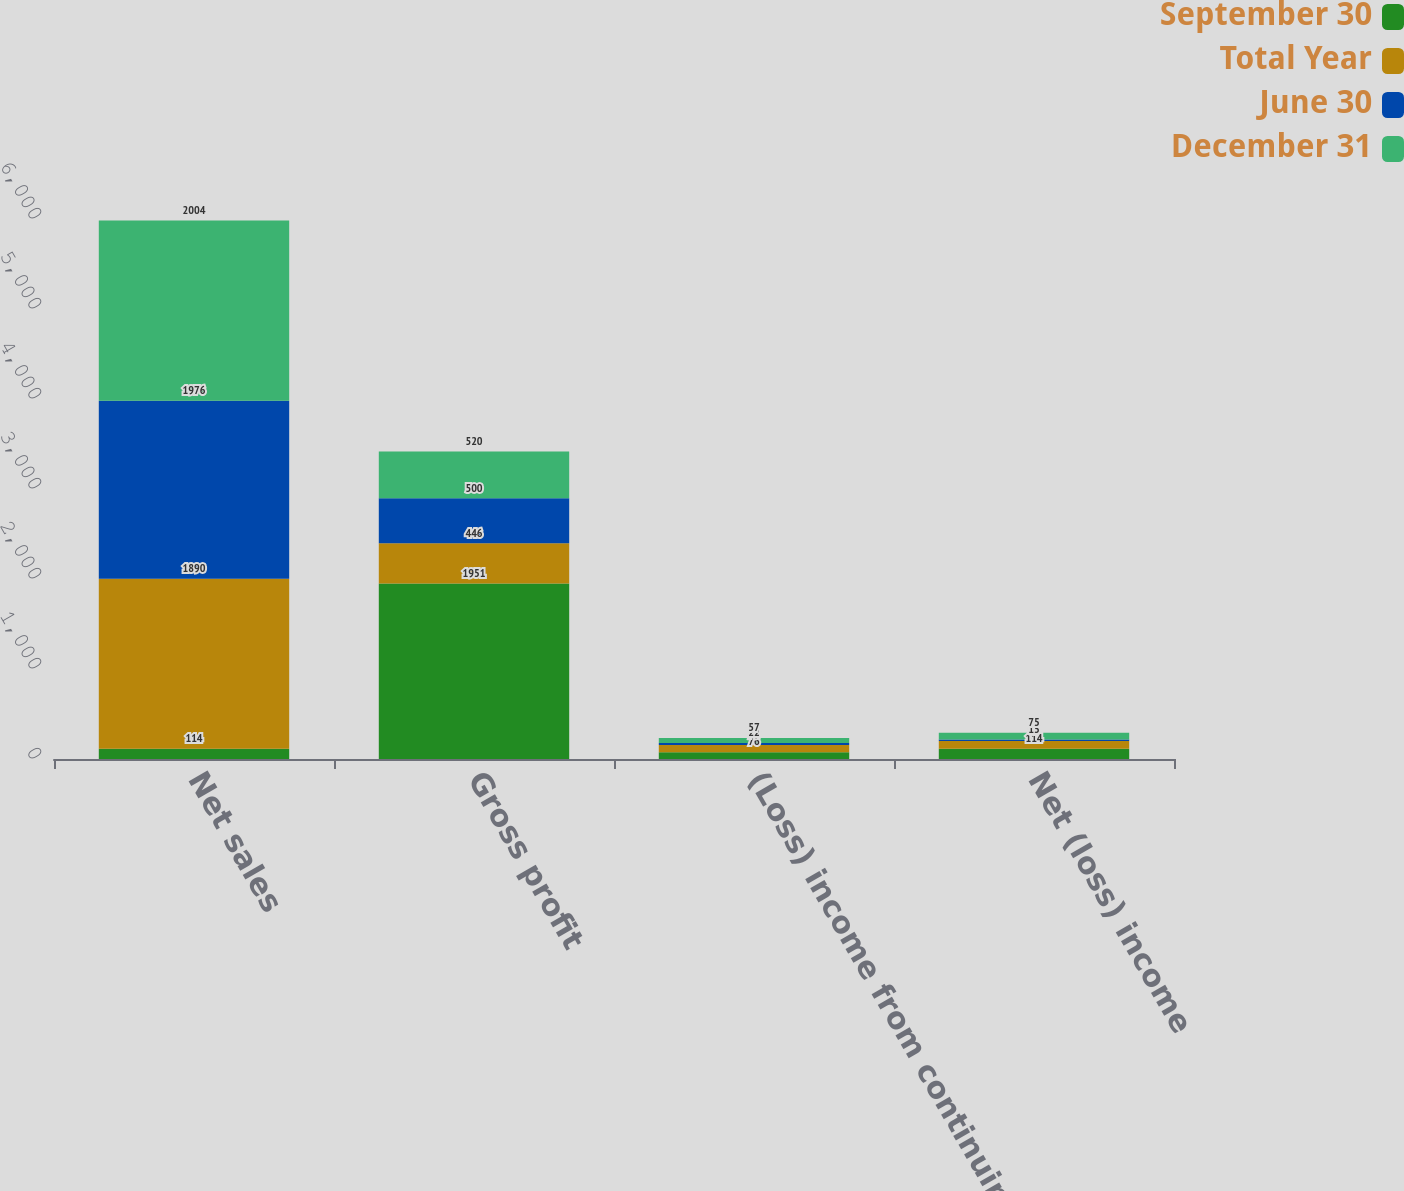<chart> <loc_0><loc_0><loc_500><loc_500><stacked_bar_chart><ecel><fcel>Net sales<fcel>Gross profit<fcel>(Loss) income from continuing<fcel>Net (loss) income<nl><fcel>September 30<fcel>114<fcel>1951<fcel>76<fcel>114<nl><fcel>Total Year<fcel>1890<fcel>446<fcel>79<fcel>87<nl><fcel>June 30<fcel>1976<fcel>500<fcel>22<fcel>15<nl><fcel>December 31<fcel>2004<fcel>520<fcel>57<fcel>75<nl></chart> 